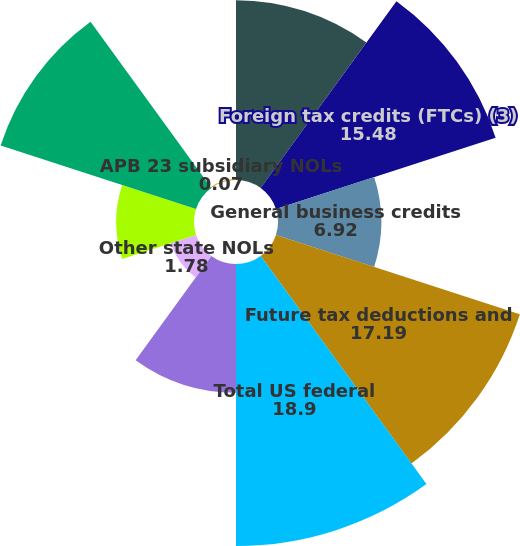Convert chart. <chart><loc_0><loc_0><loc_500><loc_500><pie_chart><fcel>Net operating losses (NOLs)<fcel>Foreign tax credits (FTCs) (3)<fcel>General business credits<fcel>Future tax deductions and<fcel>Total US federal<fcel>New York NOLs<fcel>Other state NOLs<fcel>Future tax deductions<fcel>Total state and local<fcel>APB 23 subsidiary NOLs<nl><fcel>12.05%<fcel>15.48%<fcel>6.92%<fcel>17.19%<fcel>18.9%<fcel>8.63%<fcel>1.78%<fcel>5.21%<fcel>13.77%<fcel>0.07%<nl></chart> 